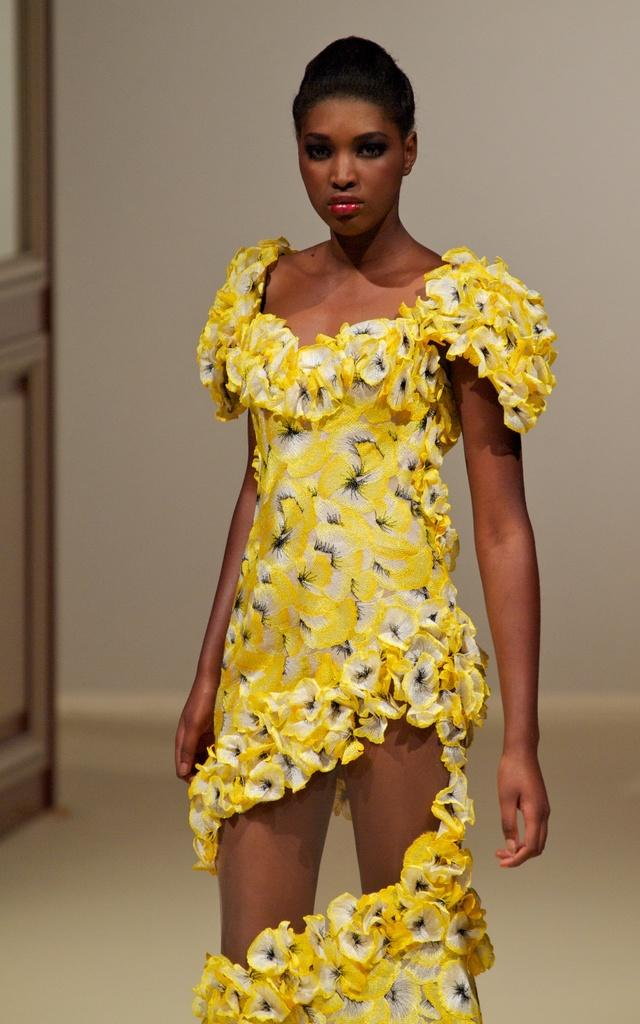What is the woman in the image wearing? The woman is wearing a yellow dress. Can you describe the background of the image? There is a wall in the background of the image, and there is also an object present. What color is the woman's dress? The woman's dress is yellow. What type of note is the woman holding in the image? There is no note visible in the image; the woman is not holding anything. 